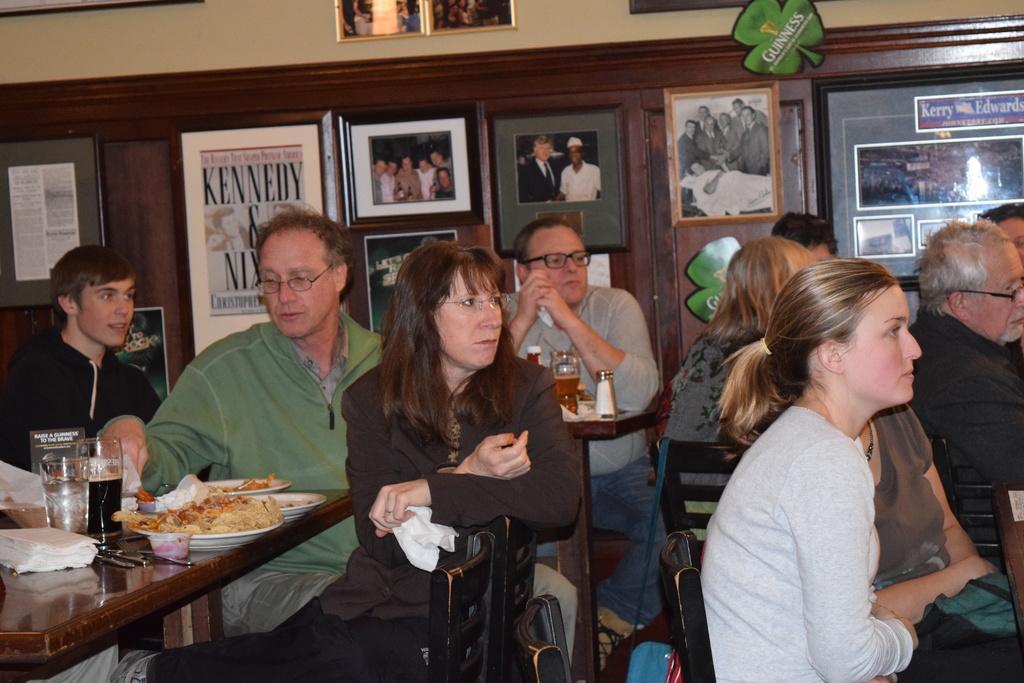Describe this image in one or two sentences. In this image there are group of people sitting on chairs. To the left corner there is a table, some glasses, tissues and food are placed on that table. In the middle there is a woman she wear a black dress and also spectacles, she is holding a tissue. To the right there is an another woman,she is wearing a grey T shirt and starting. In the background there is wall full of photo frames. To the left corner there is a man and he is wearing a black. 